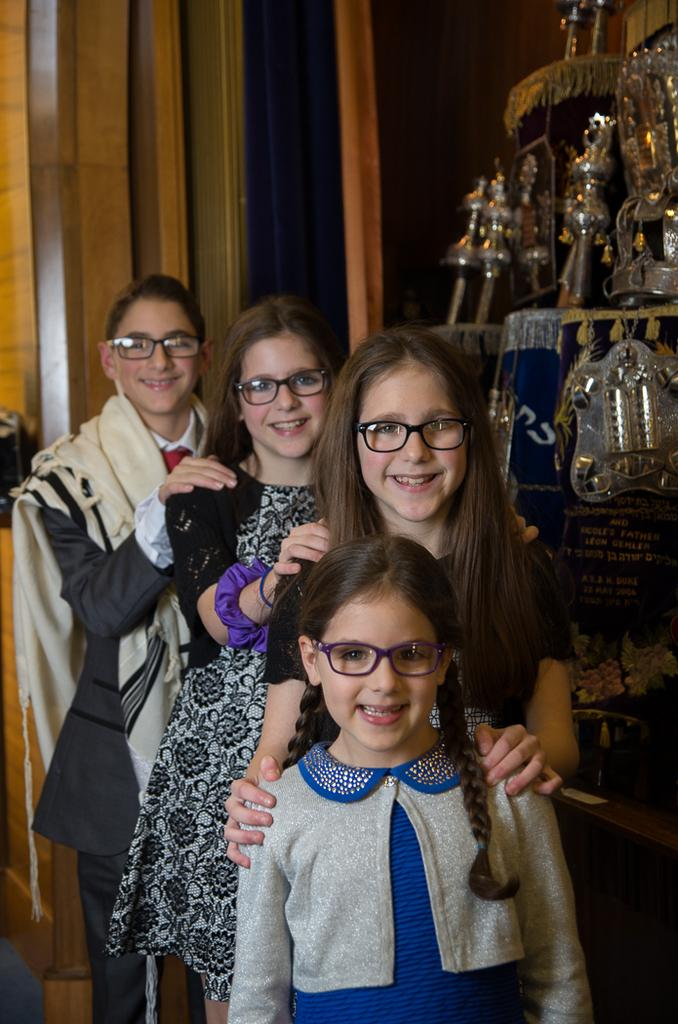How many people are present in the image? There are four people standing in the image. What is the facial expression of the people in the image? The people are smiling. What accessory are the people wearing in the image? The people are wearing spectacles. Can you describe any objects or structures in the image? There appears to be an object in the image, and there is a pillar in the background. What type of throat lozenges are the people using in the image? There is no indication in the image that the people are using throat lozenges, so it cannot be determined from the picture. 